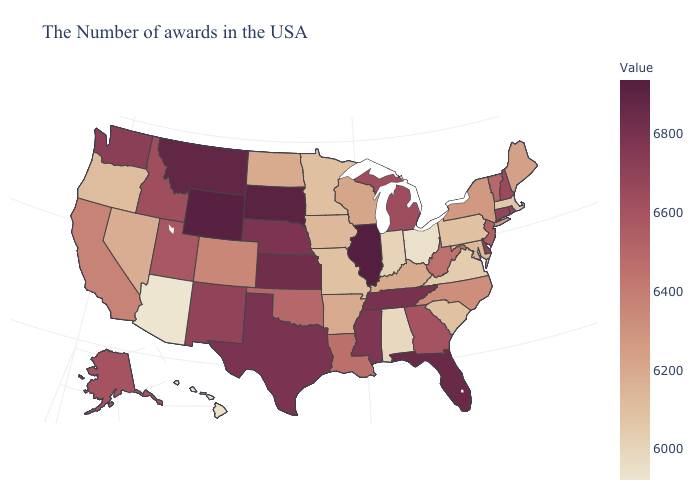Does Tennessee have a lower value than Hawaii?
Quick response, please. No. Does Connecticut have the highest value in the Northeast?
Concise answer only. Yes. Which states have the lowest value in the USA?
Be succinct. Arizona. 